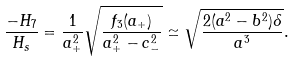<formula> <loc_0><loc_0><loc_500><loc_500>\frac { - H _ { 7 } } { H _ { s } } = \frac { 1 } { a _ { + } ^ { 2 } } \sqrt { \frac { f _ { 3 } ( a _ { + } ) } { a _ { + } ^ { 2 } - c _ { - } ^ { 2 } } } \simeq \sqrt { \frac { 2 ( a ^ { 2 } - b ^ { 2 } ) \delta } { a ^ { 3 } } } .</formula> 